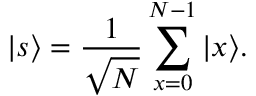Convert formula to latex. <formula><loc_0><loc_0><loc_500><loc_500>| s \rangle = { \frac { 1 } { \sqrt { N } } } \sum _ { x = 0 } ^ { N - 1 } | x \rangle .</formula> 